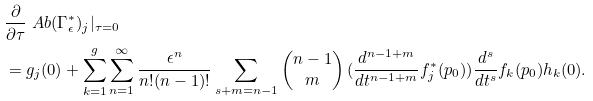Convert formula to latex. <formula><loc_0><loc_0><loc_500><loc_500>& \frac { \partial } { \partial \tau } \ A b ( \Gamma _ { \epsilon } ^ { \ast } ) _ { j } | _ { \tau = 0 } \\ & = g _ { j } ( 0 ) + \sum _ { k = 1 } ^ { g } \sum _ { n = 1 } ^ { \infty } \frac { \epsilon ^ { n } } { n ! ( n - 1 ) ! } \sum _ { s + m = n - 1 } \begin{pmatrix} n - 1 \\ m \end{pmatrix} ( \frac { d ^ { n - 1 + m } } { d t ^ { n - 1 + m } } f ^ { \ast } _ { j } ( p _ { 0 } ) ) \frac { d ^ { s } } { d t ^ { s } } f _ { k } ( p _ { 0 } ) h _ { k } ( 0 ) .</formula> 